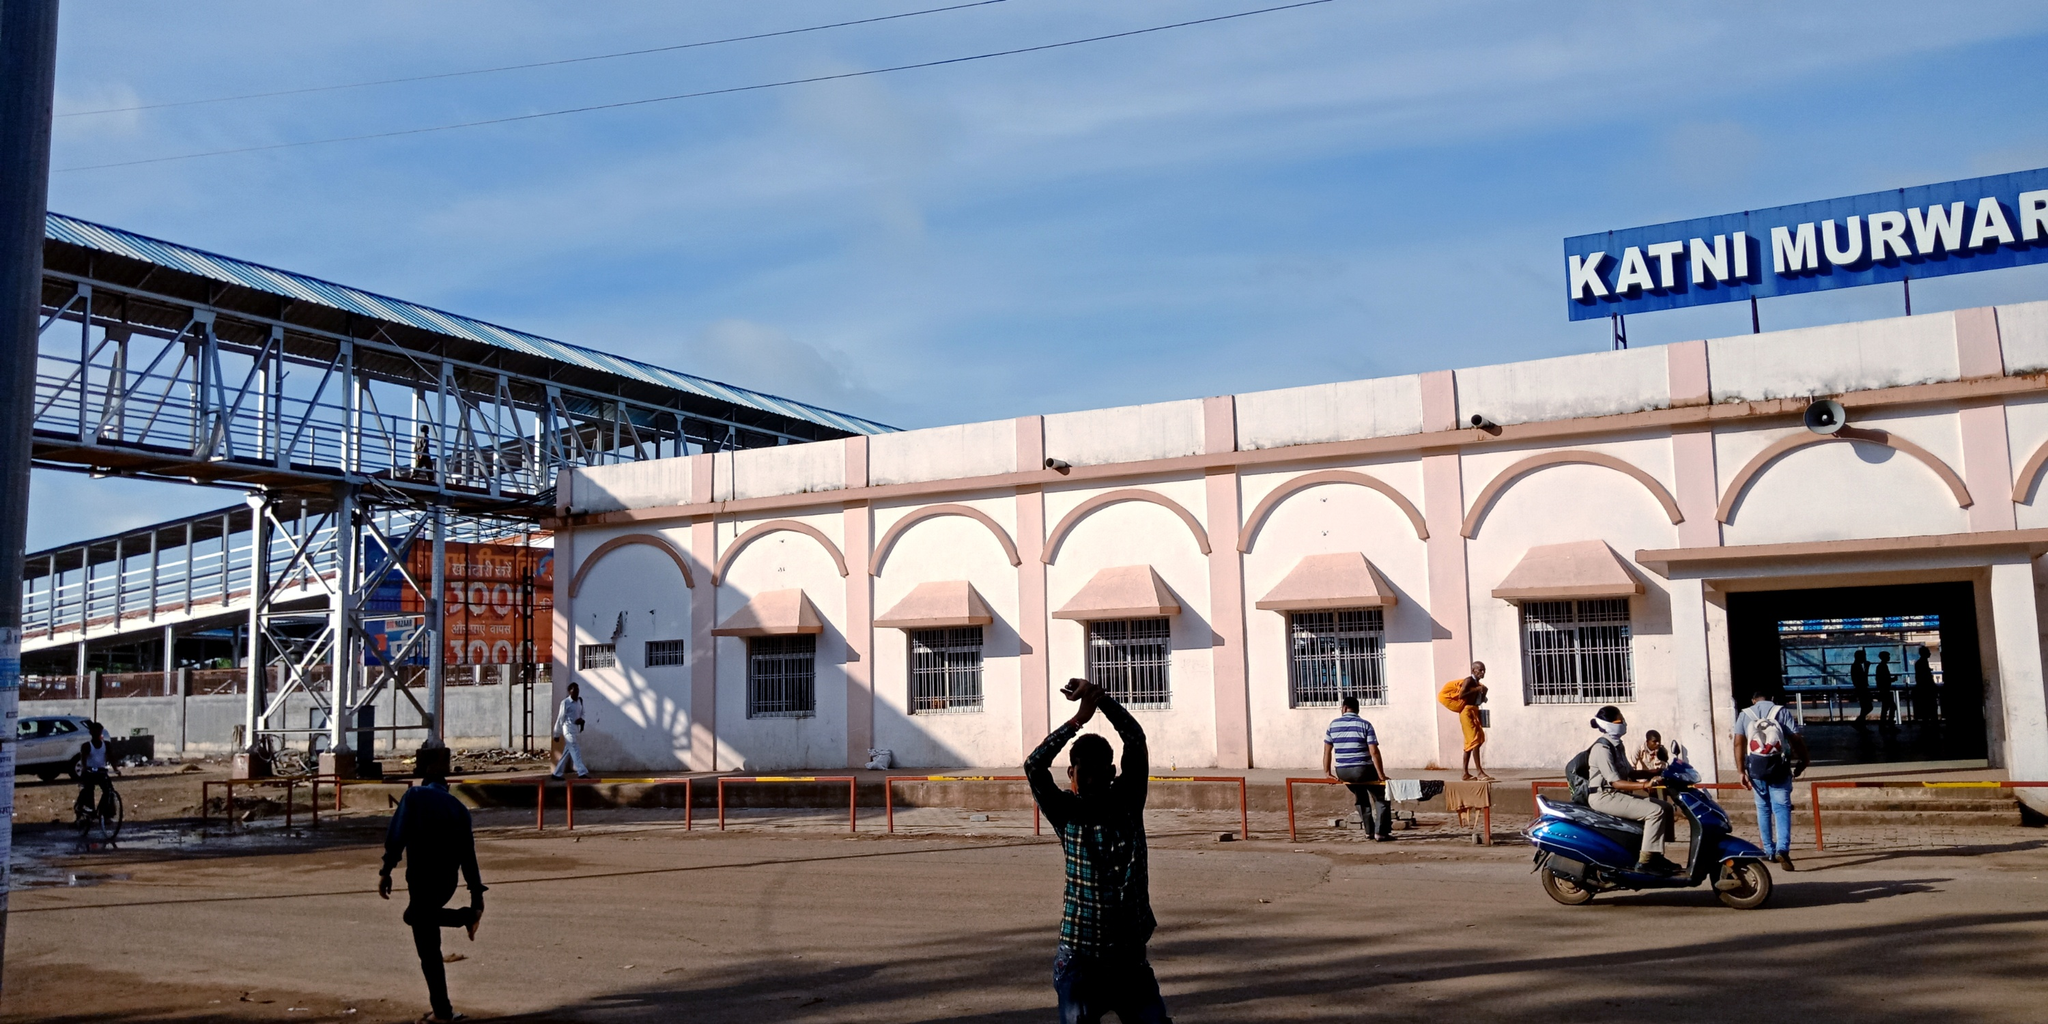What are the key elements in this picture? The image prominently features the Katni Murwara railway station in India, distinguished by its white and pink facade and bold blue signage. Important elements include the pedestrian bridge, suggesting connectivity and the station's bustling nature. Several individuals are visible, including a man in a green shirt using his phone, likely capturing a photo, which adds a human interest element to the scene. A blue scooter, parked on the right, introduces a daily life aspect. The clear sky overhead with sparse clouds suggests pleasant weather, hinting at an optimal day for travel. In the background, ongoing construction is visible, indicating development or maintenance efforts at the station. 